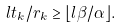Convert formula to latex. <formula><loc_0><loc_0><loc_500><loc_500>l t _ { k } / r _ { k } \geq \lfloor l \beta / \alpha \rfloor .</formula> 